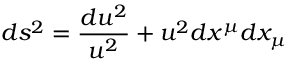<formula> <loc_0><loc_0><loc_500><loc_500>d s ^ { 2 } = { \frac { d u ^ { 2 } } { u ^ { 2 } } } + u ^ { 2 } d x ^ { \mu } d x _ { \mu }</formula> 